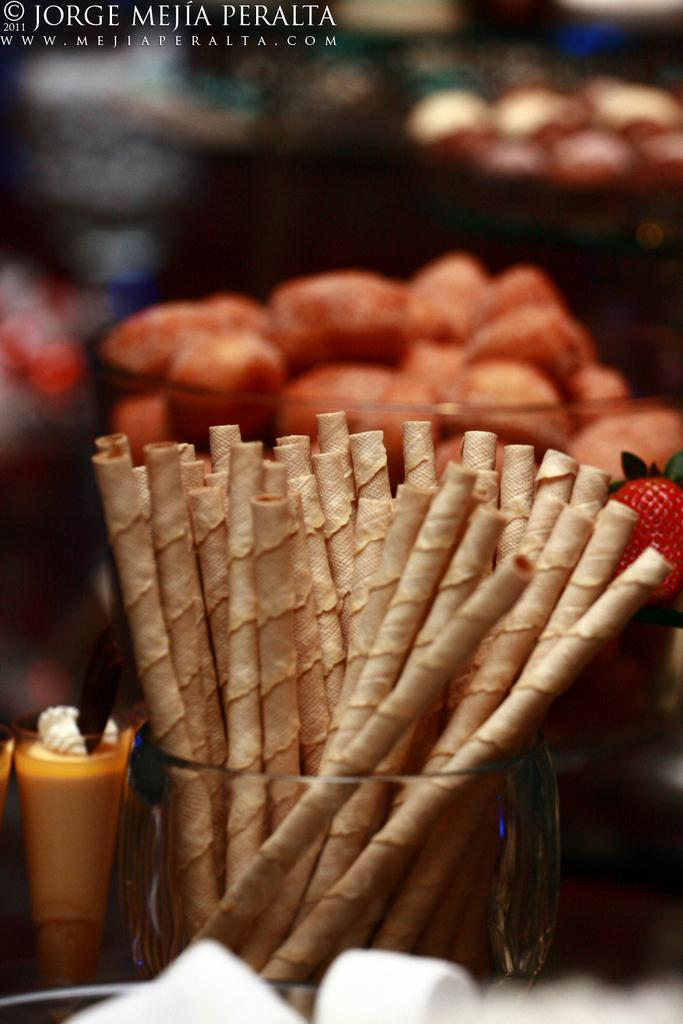What type of fruit is present in the image? There is a strawberry in the image. What type of containers are visible in the image? There are glass bowls in the image. What can be inferred about the contents of the image? There are food items in the image. Can you describe any additional features of the image? There is a watermark in the image. How does the strawberry express love in the image? The strawberry does not express love in the image; it is a fruit and does not have the ability to express emotions. 